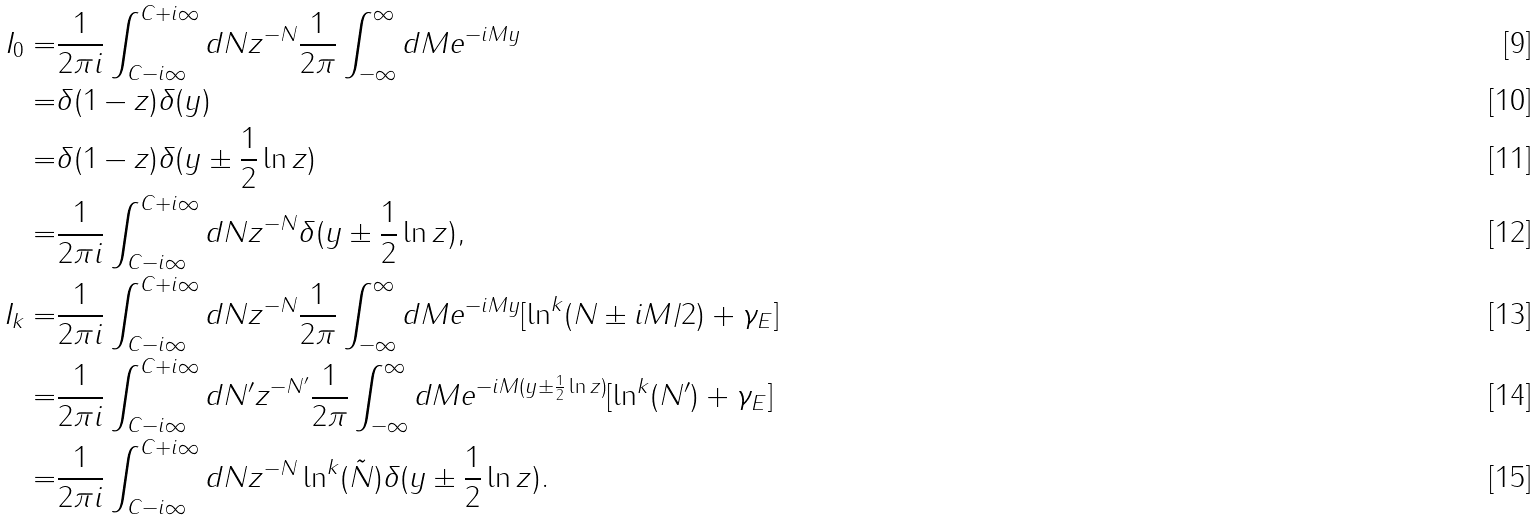<formula> <loc_0><loc_0><loc_500><loc_500>I _ { 0 } = & \frac { 1 } { 2 \pi i } \int _ { C - i \infty } ^ { C + i \infty } d N z ^ { - N } \frac { 1 } { 2 \pi } \int _ { - \infty } ^ { \infty } d M e ^ { - i M y } \\ = & \delta ( 1 - z ) \delta ( y ) \\ = & \delta ( 1 - z ) \delta ( y \pm \frac { 1 } { 2 } \ln z ) \\ = & \frac { 1 } { 2 \pi i } \int _ { C - i \infty } ^ { C + i \infty } d N z ^ { - N } \delta ( y \pm \frac { 1 } { 2 } \ln z ) , \\ I _ { k } = & \frac { 1 } { 2 \pi i } \int _ { C - i \infty } ^ { C + i \infty } d N z ^ { - N } \frac { 1 } { 2 \pi } \int _ { - \infty } ^ { \infty } d M e ^ { - i M y } [ \ln ^ { k } ( N \pm i M / 2 ) + \gamma _ { E } ] \\ = & \frac { 1 } { 2 \pi i } \int _ { C - i \infty } ^ { C + i \infty } d N ^ { \prime } z ^ { - N ^ { \prime } } \frac { 1 } { 2 \pi } \int _ { - \infty } ^ { \infty } d M e ^ { - i M ( y \pm \frac { 1 } { 2 } \ln z ) } [ \ln ^ { k } ( N ^ { \prime } ) + \gamma _ { E } ] \\ = & \frac { 1 } { 2 \pi i } \int _ { C - i \infty } ^ { C + i \infty } d N z ^ { - N } \ln ^ { k } ( \tilde { N } ) \delta ( y \pm \frac { 1 } { 2 } \ln z ) .</formula> 